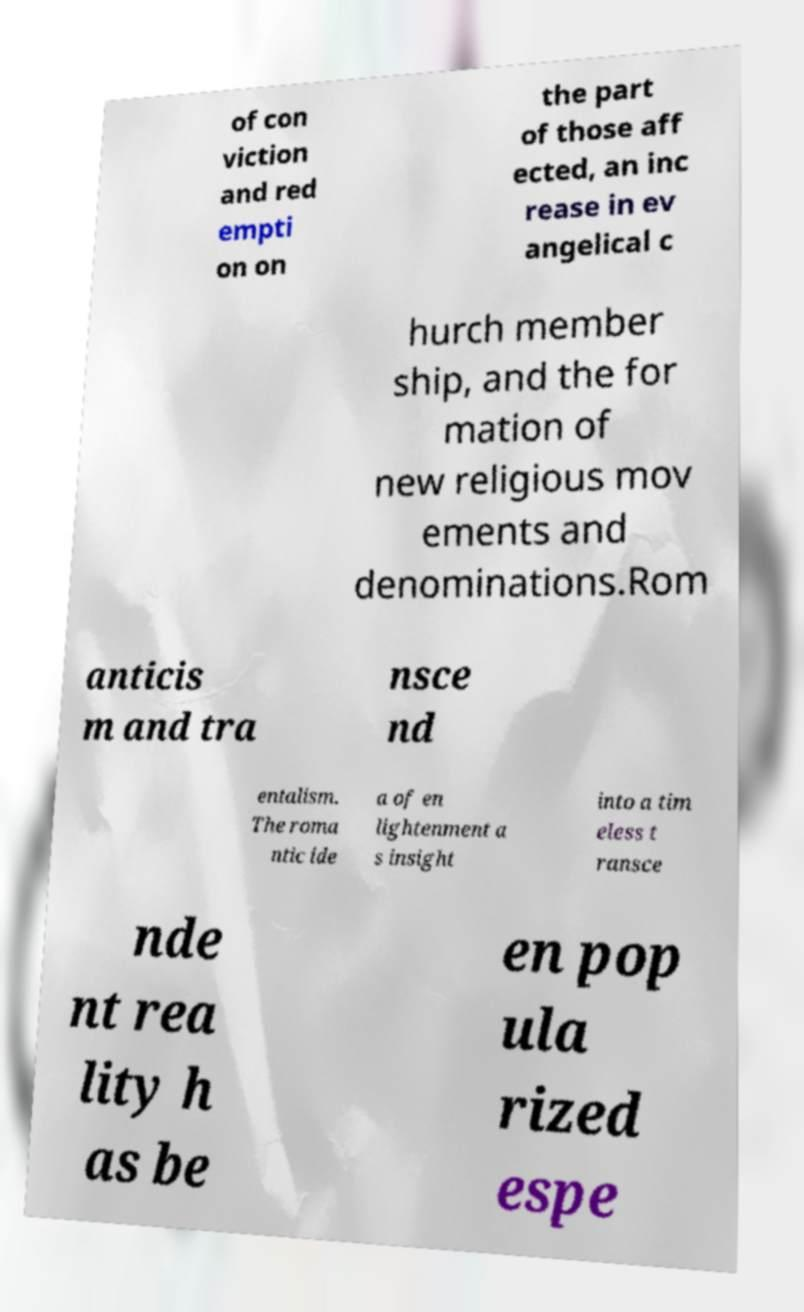What messages or text are displayed in this image? I need them in a readable, typed format. of con viction and red empti on on the part of those aff ected, an inc rease in ev angelical c hurch member ship, and the for mation of new religious mov ements and denominations.Rom anticis m and tra nsce nd entalism. The roma ntic ide a of en lightenment a s insight into a tim eless t ransce nde nt rea lity h as be en pop ula rized espe 